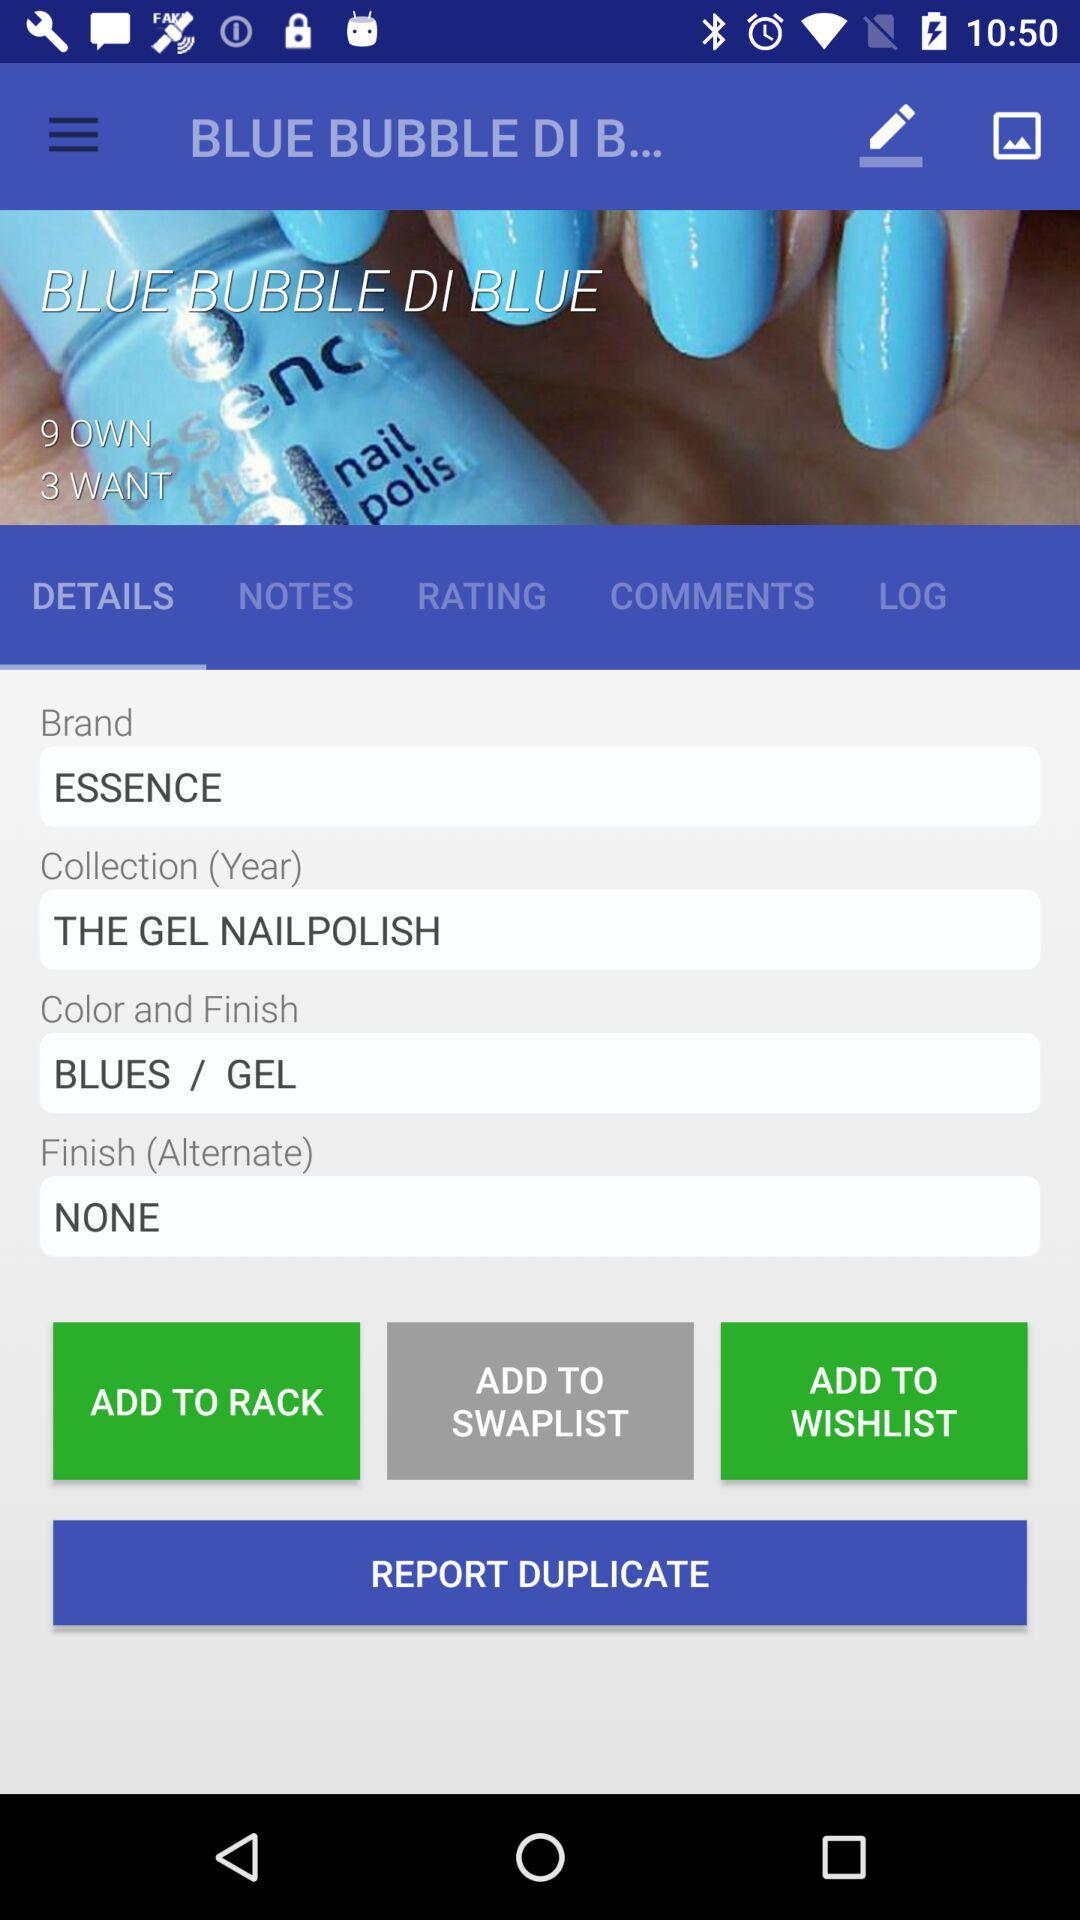Which tab is selected? The selected tab is "DETAILS". 